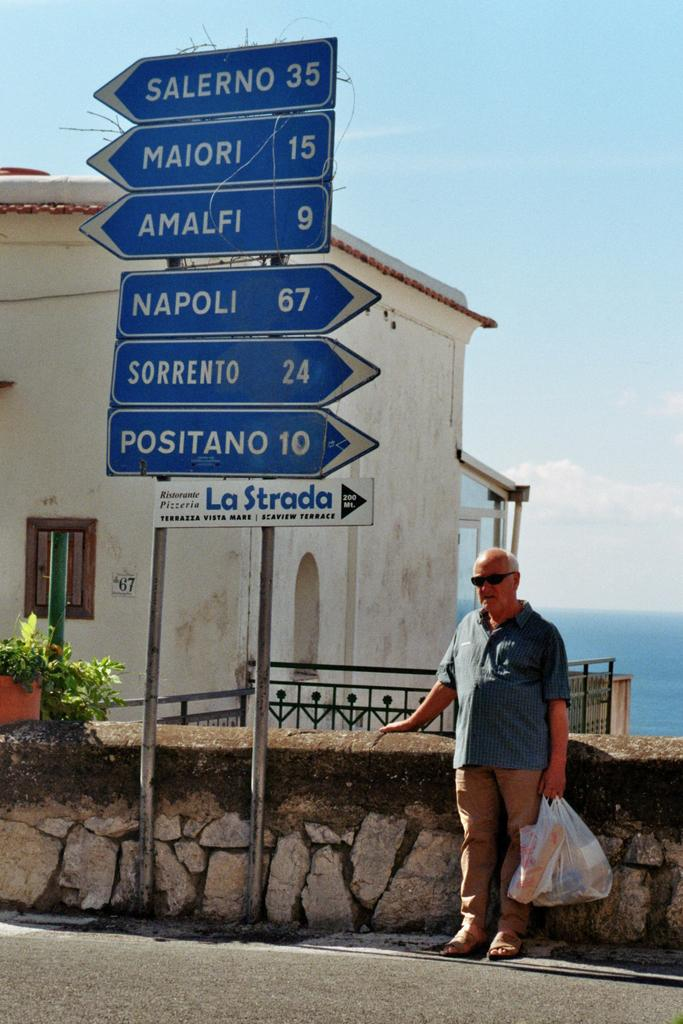What is the person in the image holding? The person is standing and holding a plastic bag. What can be seen in the image besides the person? There are sign boards, rods, a plant, a fence, a building, water, and the sky visible in the image. Can you describe the background of the image? The background of the image includes a plant, a fence, a building, water, and the sky. What might the sign boards be used for? The sign boards could be used for providing information or directions. How many legs does the bridge have in the image? There is no bridge present in the image, so it is not possible to determine the number of legs it might have. 